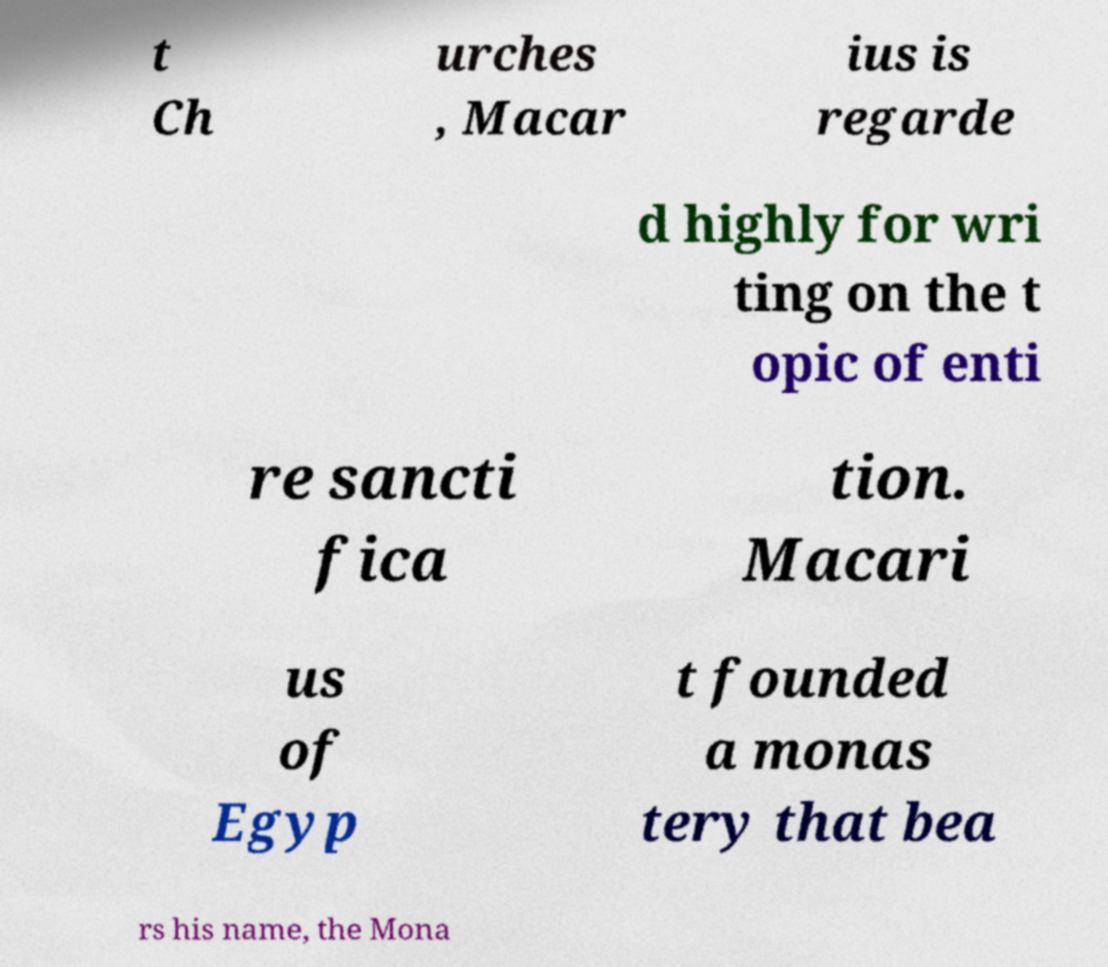Can you read and provide the text displayed in the image?This photo seems to have some interesting text. Can you extract and type it out for me? t Ch urches , Macar ius is regarde d highly for wri ting on the t opic of enti re sancti fica tion. Macari us of Egyp t founded a monas tery that bea rs his name, the Mona 